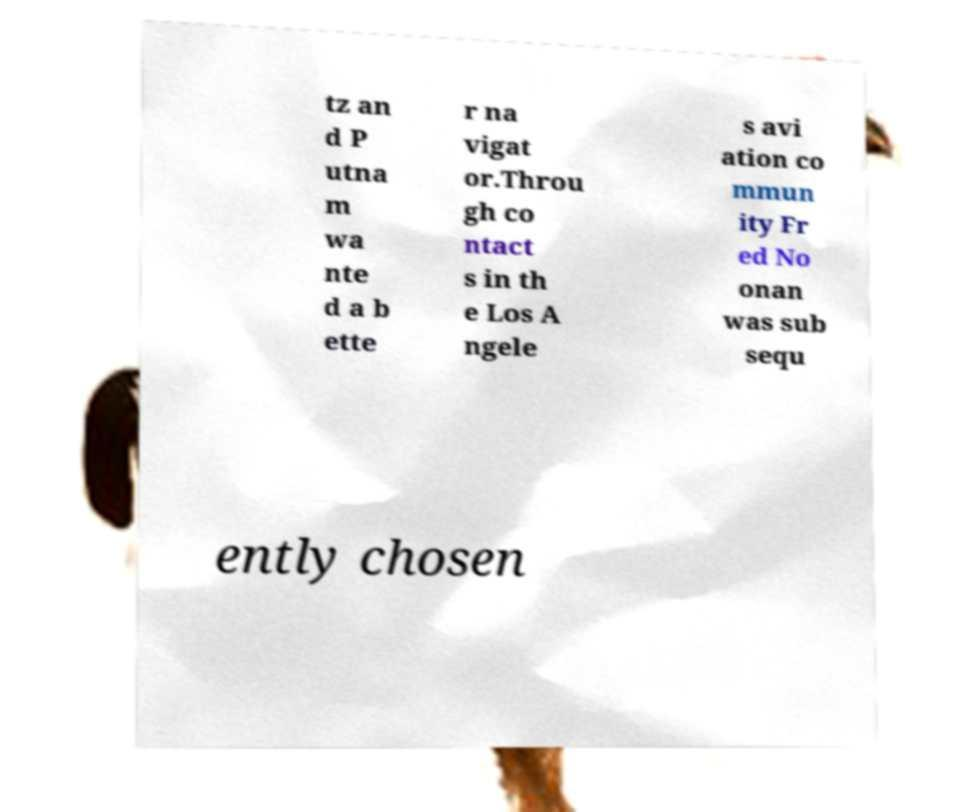Could you assist in decoding the text presented in this image and type it out clearly? tz an d P utna m wa nte d a b ette r na vigat or.Throu gh co ntact s in th e Los A ngele s avi ation co mmun ity Fr ed No onan was sub sequ ently chosen 